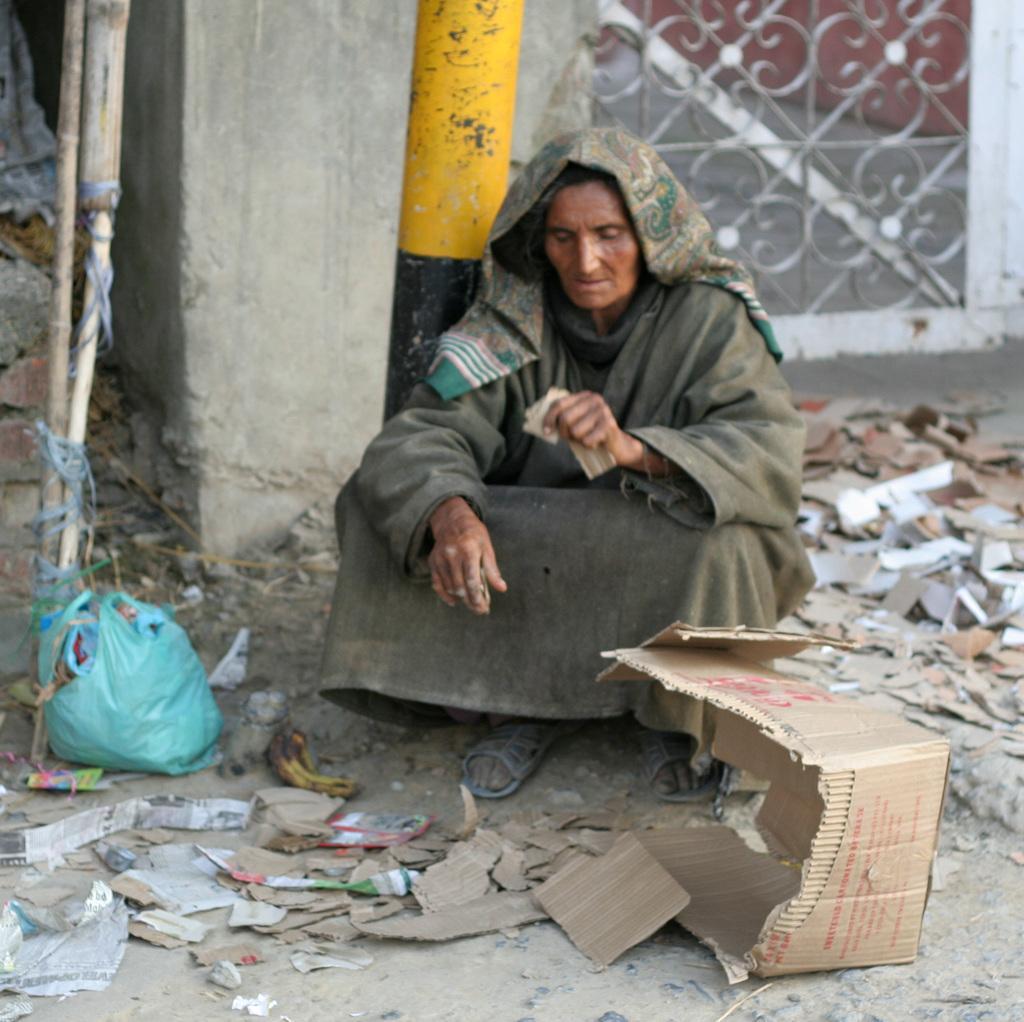Describe this image in one or two sentences. On the left side of the image we can see a stick and a plastic bag. In the middle of the image we can see a pole, a lady is sitting on the floor and a cotton box. On the right side of the image we can see an iron window and some objects which are in blue. 